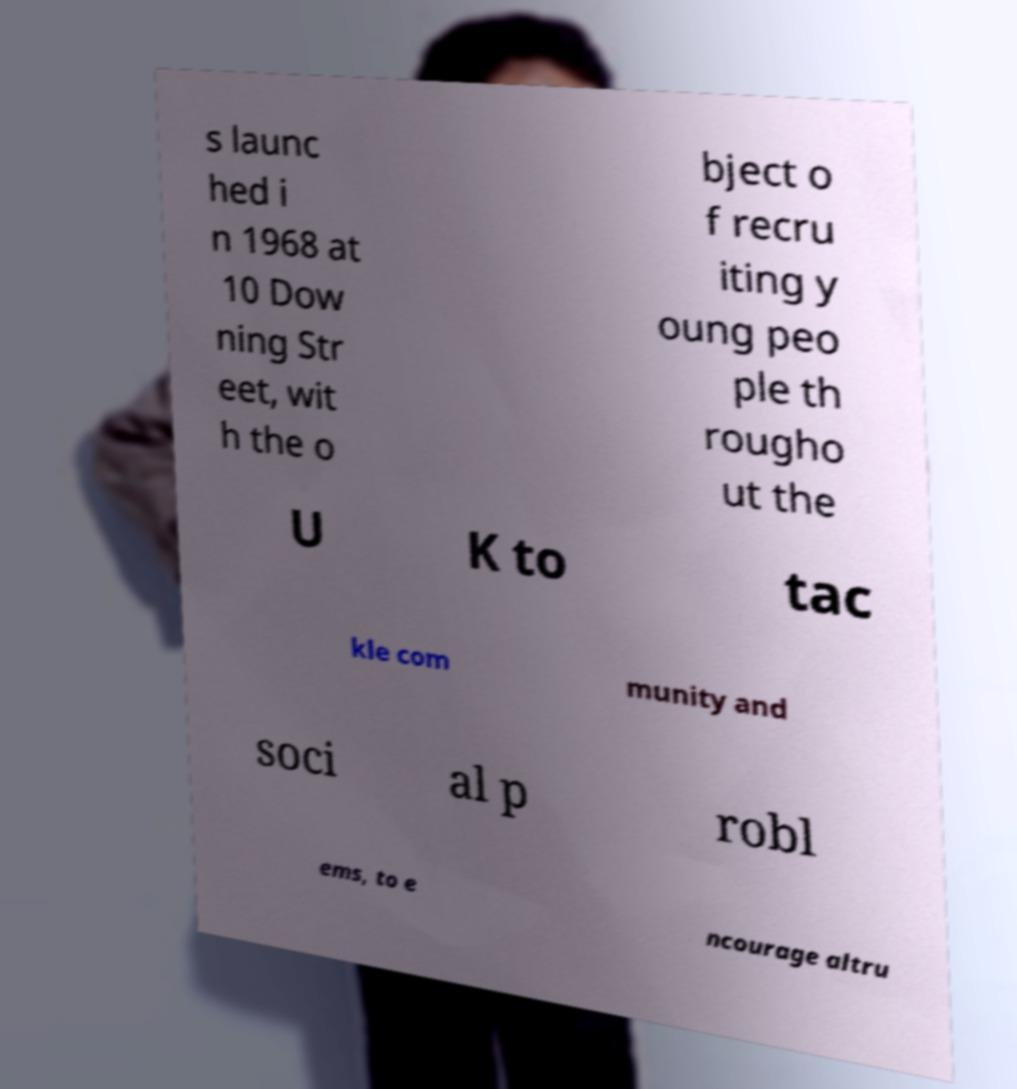Could you extract and type out the text from this image? s launc hed i n 1968 at 10 Dow ning Str eet, wit h the o bject o f recru iting y oung peo ple th rougho ut the U K to tac kle com munity and soci al p robl ems, to e ncourage altru 